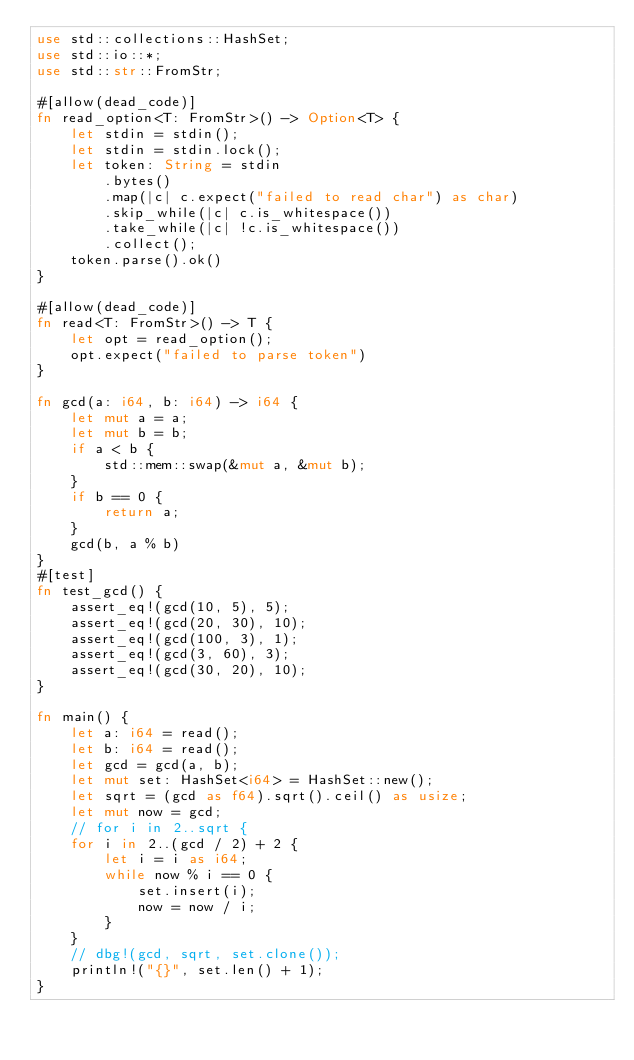Convert code to text. <code><loc_0><loc_0><loc_500><loc_500><_Rust_>use std::collections::HashSet;
use std::io::*;
use std::str::FromStr;

#[allow(dead_code)]
fn read_option<T: FromStr>() -> Option<T> {
    let stdin = stdin();
    let stdin = stdin.lock();
    let token: String = stdin
        .bytes()
        .map(|c| c.expect("failed to read char") as char)
        .skip_while(|c| c.is_whitespace())
        .take_while(|c| !c.is_whitespace())
        .collect();
    token.parse().ok()
}

#[allow(dead_code)]
fn read<T: FromStr>() -> T {
    let opt = read_option();
    opt.expect("failed to parse token")
}

fn gcd(a: i64, b: i64) -> i64 {
    let mut a = a;
    let mut b = b;
    if a < b {
        std::mem::swap(&mut a, &mut b);
    }
    if b == 0 {
        return a;
    }
    gcd(b, a % b)
}
#[test]
fn test_gcd() {
    assert_eq!(gcd(10, 5), 5);
    assert_eq!(gcd(20, 30), 10);
    assert_eq!(gcd(100, 3), 1);
    assert_eq!(gcd(3, 60), 3);
    assert_eq!(gcd(30, 20), 10);
}

fn main() {
    let a: i64 = read();
    let b: i64 = read();
    let gcd = gcd(a, b);
    let mut set: HashSet<i64> = HashSet::new();
    let sqrt = (gcd as f64).sqrt().ceil() as usize;
    let mut now = gcd;
    // for i in 2..sqrt {
    for i in 2..(gcd / 2) + 2 {
        let i = i as i64;
        while now % i == 0 {
            set.insert(i);
            now = now / i;
        }
    }
    // dbg!(gcd, sqrt, set.clone());
    println!("{}", set.len() + 1);
}
</code> 